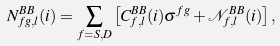Convert formula to latex. <formula><loc_0><loc_0><loc_500><loc_500>N _ { f g , l } ^ { B B } ( i ) = \sum _ { { f } = S , D } \left [ C _ { { f } , l } ^ { B B } ( i ) \sigma ^ { f g } + \mathcal { N } _ { { f } , l } ^ { B B } ( i ) \right ] ,</formula> 